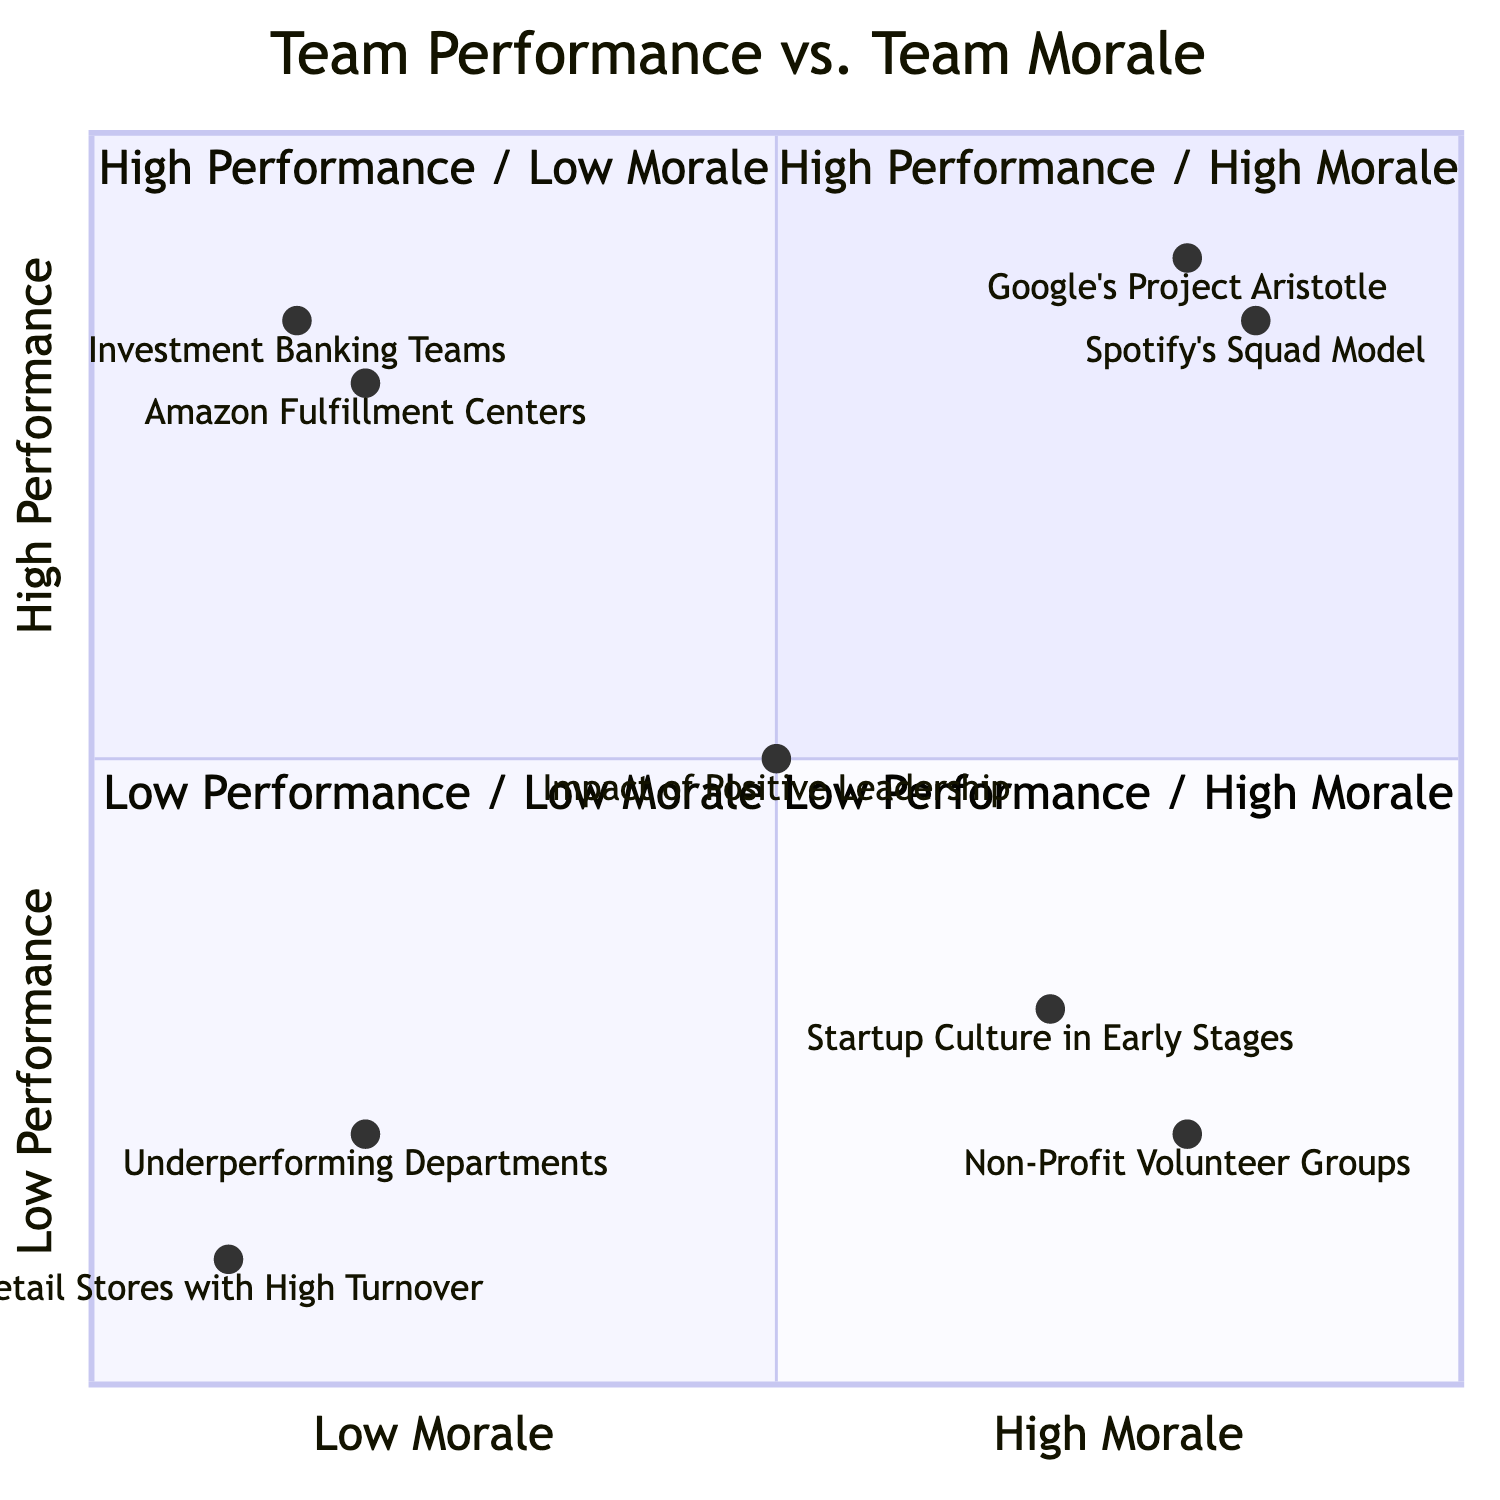What team appears in the High Performance / High Morale quadrant? In the High Performance / High Morale quadrant, the examples listed include "Google's Project Aristotle" and "Spotify's Squad Model." Therefore, either of these would answer the question.
Answer: Google's Project Aristotle How many teams are in the Low Performance / Low Morale quadrant? The Low Performance / Low Morale quadrant has two examples listed: "Underperforming Departments in Large Corporations" and "Retail Stores with High Turnover." Therefore, there are 2 teams in this quadrant.
Answer: 2 What is the impact noted for positive leadership in the diagram? The annotation states that "Leaders who nurture team unity and lead by example can shift teams towards higher performance and higher morale." Thus, the impact of positive leadership is one of elevation in both performance and morale.
Answer: Shift teams towards higher performance and morale Which quadrant has teams with both low performance and high morale? The quadrant that contains teams with low performance and high morale is "Low Performance / High Morale." It describes teams that may require better direction and goal alignment.
Answer: Low Performance / High Morale What common trait do teams in the High Performance / Low Morale quadrant share? Teams in the High Performance / Low Morale quadrant, such as "Amazon Fulfillment Centers" and "Investment Banking Teams," exhibit high efficiency but have reported instances of worker dissatisfaction, indicating a lack of morale despite high performance.
Answer: High efficiency but low morale Which example represents a scenario with high morale but low performance? The example representing high morale but low performance is "Non-Profit Volunteer Groups." They have high commitment to their cause but may lack effective operational strategies.
Answer: Non-Profit Volunteer Groups What is the description for the Low Performance / High Morale quadrant? The description for the Low Performance / High Morale quadrant emphasizes that these teams may require better direction and goal alignment, highlighting the need for enhanced guidance.
Answer: Require better direction and goal alignment In which quadrant are the investment banking teams located? Investment banking teams are located in the High Performance / Low Morale quadrant, which indicates they perform well but have low morale primarily due to work-life balance issues.
Answer: High Performance / Low Morale 